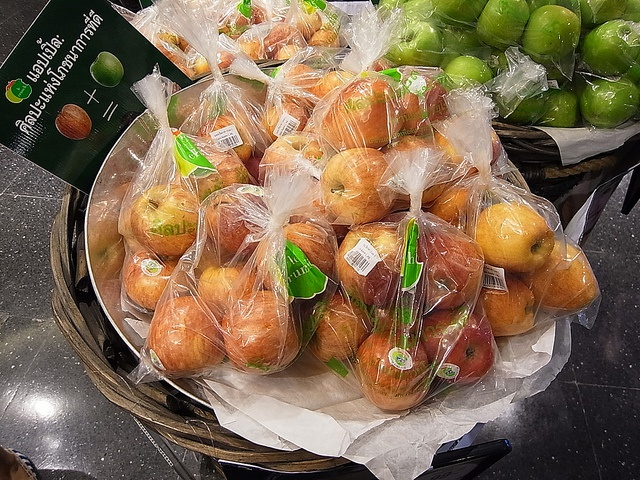Describe the objects in this image and their specific colors. I can see apple in black, maroon, brown, and olive tones, apple in black, darkgreen, and olive tones, apple in black, tan, and brown tones, book in black, gray, lightgray, and darkgray tones, and apple in black, tan, brown, and gray tones in this image. 